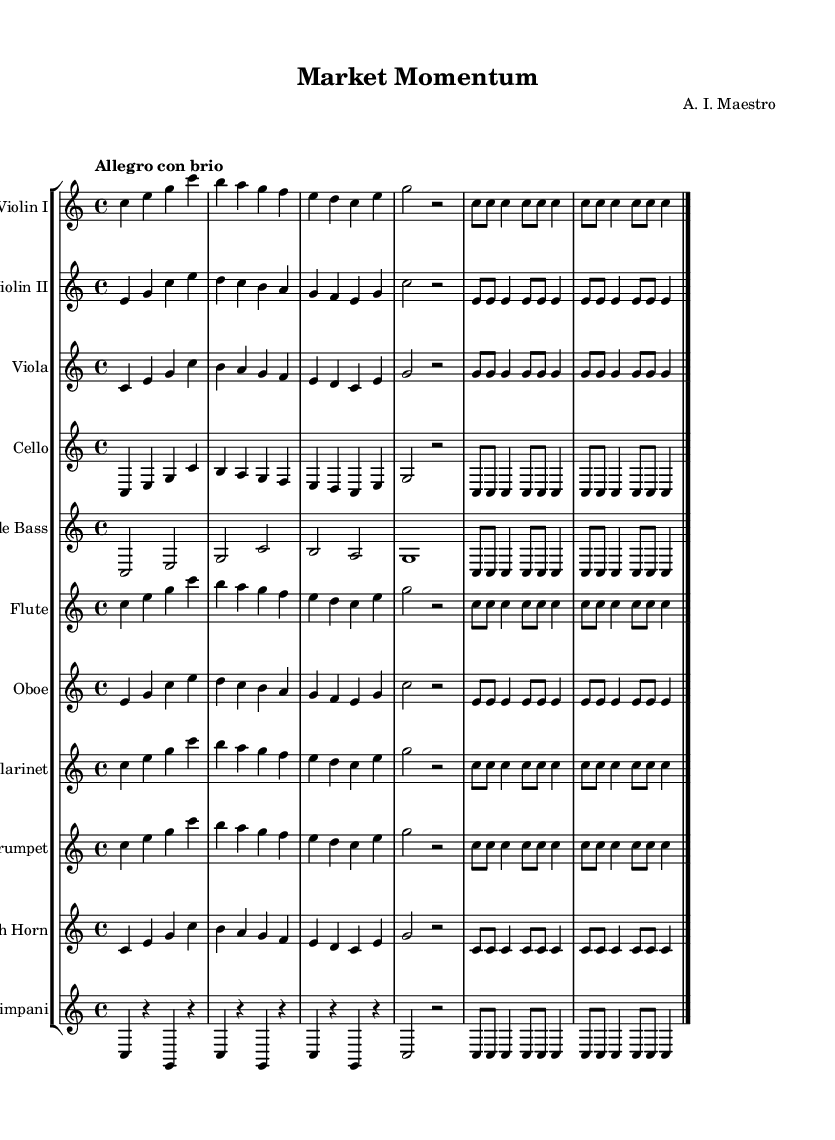What is the key signature of this music? The key signature is C major, which has no sharps or flats.
Answer: C major What is the time signature of this music? The time signature indicated in the sheet music is 4/4, meaning there are four beats in each measure.
Answer: 4/4 What is the tempo marking for this music? The tempo marking shown in the sheet music is "Allegro con brio," suggesting a lively tempo with a sense of vigor.
Answer: Allegro con brio How many instruments are in this symphony? There are ten different instruments listed in the score, including strings, woodwinds, and brass.
Answer: Ten What is the first note played by the Violin I? The first note shown for Violin I is a C note, which is the root of the C major scale.
Answer: C Which instruments play the same musical line as the Cello? The musical line for the Cello is the same as that for Violin I and Viola, as they share the same notes throughout the piece.
Answer: Violin I, Viola How many measures are repeated in the flute section? The flute section has a repeated section of four measures specified in the score.
Answer: Four 